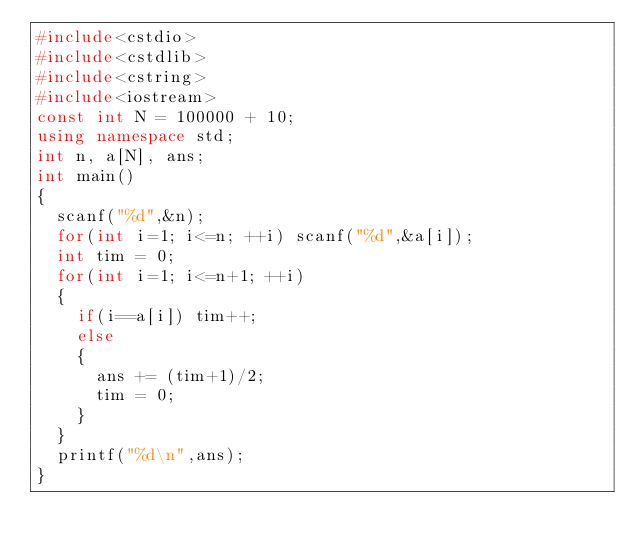<code> <loc_0><loc_0><loc_500><loc_500><_C++_>#include<cstdio>
#include<cstdlib>
#include<cstring>
#include<iostream>
const int N = 100000 + 10;
using namespace std;
int n, a[N], ans;
int main()
{
  scanf("%d",&n);
  for(int i=1; i<=n; ++i) scanf("%d",&a[i]);
  int tim = 0;
  for(int i=1; i<=n+1; ++i)
  {
    if(i==a[i]) tim++;
    else
    {
      ans += (tim+1)/2;
	  tim = 0;
	}
  }
  printf("%d\n",ans);
}</code> 